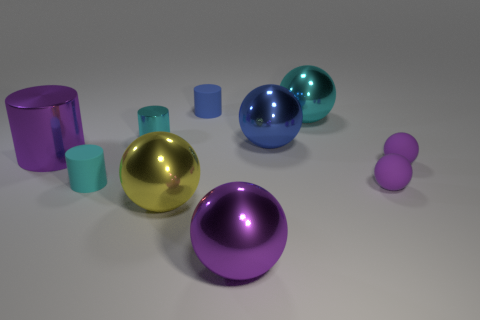What number of other things are made of the same material as the big blue object?
Offer a very short reply. 5. How many small objects are cyan metallic balls or rubber cylinders?
Provide a succinct answer. 2. Are there the same number of small matte things that are in front of the purple metallic cylinder and cylinders?
Offer a terse response. No. Are there any large things that are on the right side of the large purple metal object in front of the big yellow metallic ball?
Give a very brief answer. Yes. What number of other things are the same color as the big metallic cylinder?
Offer a terse response. 3. The large cylinder is what color?
Offer a terse response. Purple. There is a thing that is in front of the purple metal cylinder and to the left of the large yellow object; what is its size?
Keep it short and to the point. Small. How many objects are either big shiny spheres in front of the large cyan metallic thing or large blue balls?
Your answer should be compact. 3. What shape is the blue thing that is the same material as the large yellow thing?
Your answer should be compact. Sphere. The large cyan object has what shape?
Offer a terse response. Sphere. 